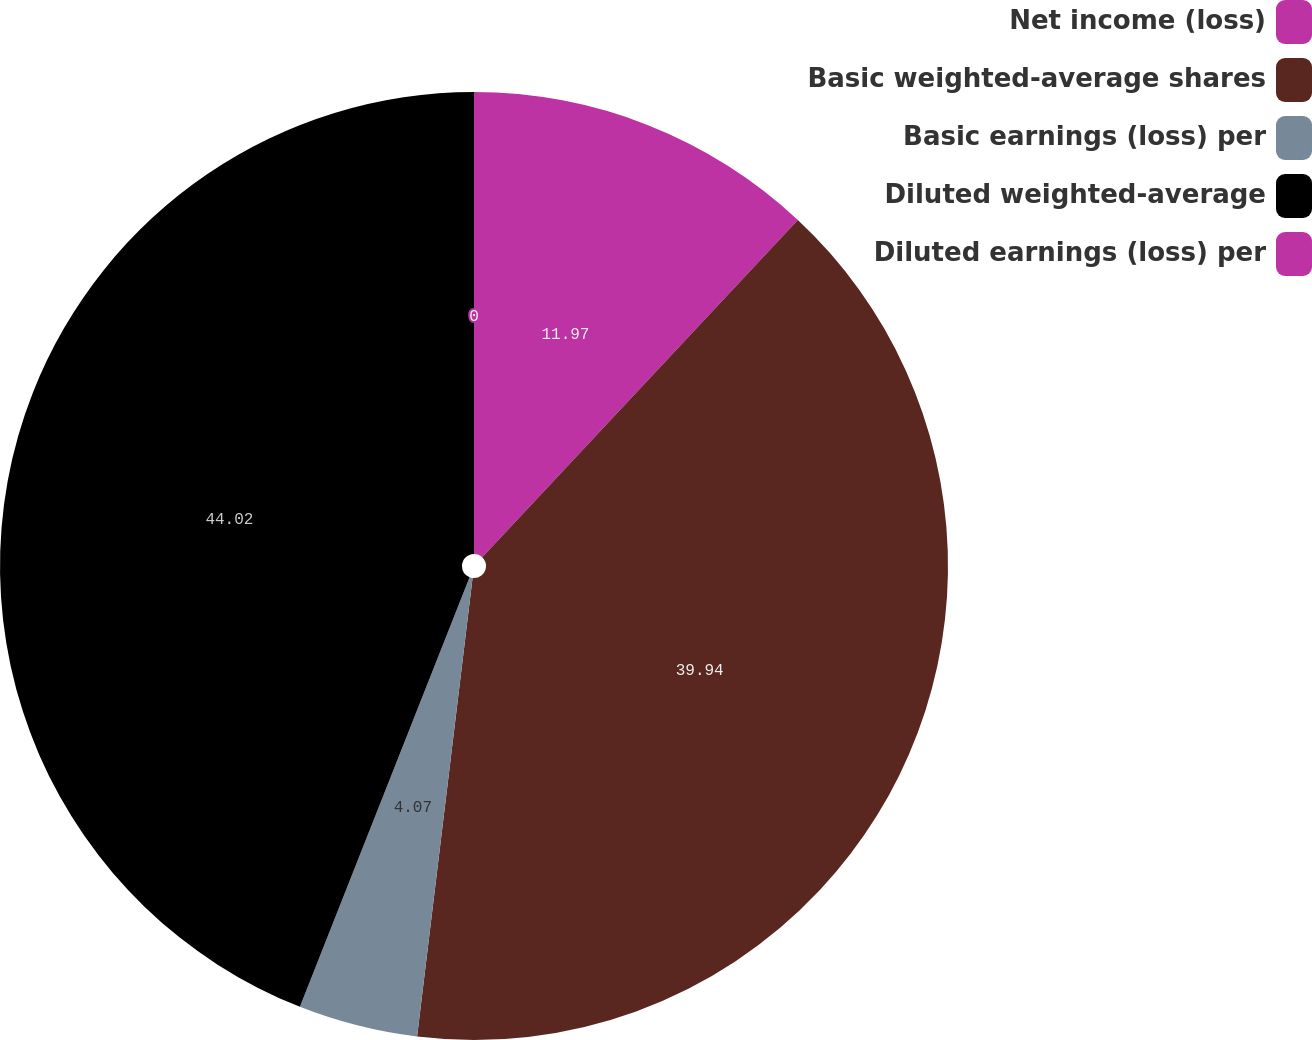<chart> <loc_0><loc_0><loc_500><loc_500><pie_chart><fcel>Net income (loss)<fcel>Basic weighted-average shares<fcel>Basic earnings (loss) per<fcel>Diluted weighted-average<fcel>Diluted earnings (loss) per<nl><fcel>11.97%<fcel>39.94%<fcel>4.07%<fcel>44.01%<fcel>0.0%<nl></chart> 